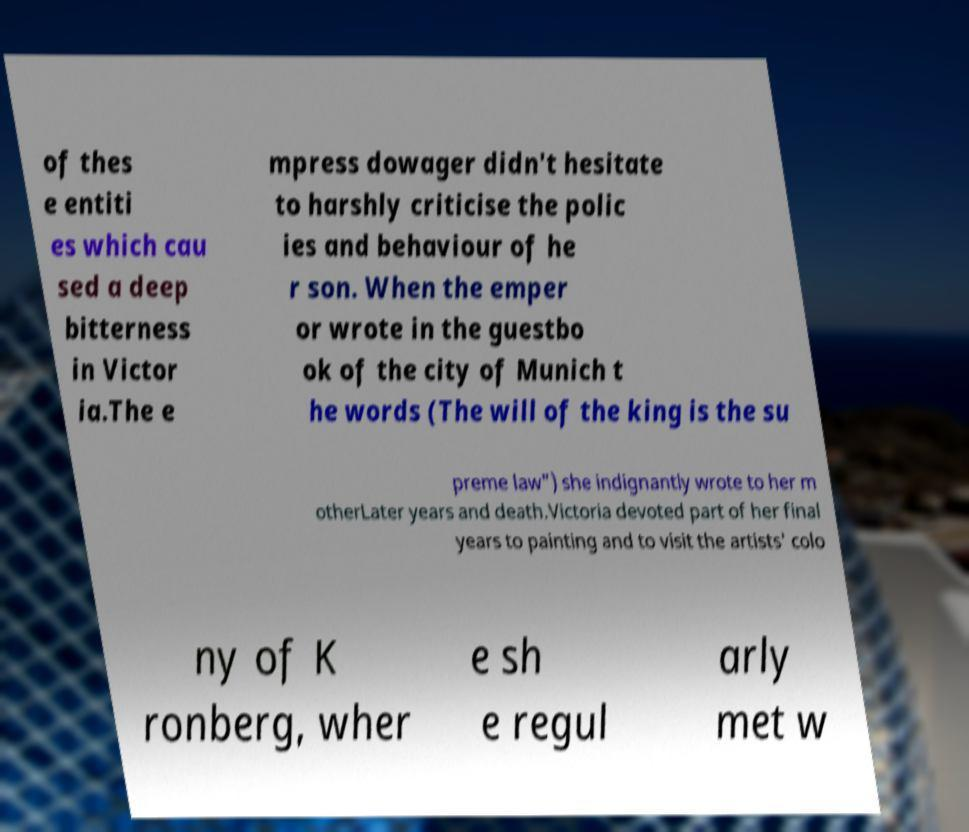I need the written content from this picture converted into text. Can you do that? of thes e entiti es which cau sed a deep bitterness in Victor ia.The e mpress dowager didn't hesitate to harshly criticise the polic ies and behaviour of he r son. When the emper or wrote in the guestbo ok of the city of Munich t he words (The will of the king is the su preme law") she indignantly wrote to her m otherLater years and death.Victoria devoted part of her final years to painting and to visit the artists' colo ny of K ronberg, wher e sh e regul arly met w 